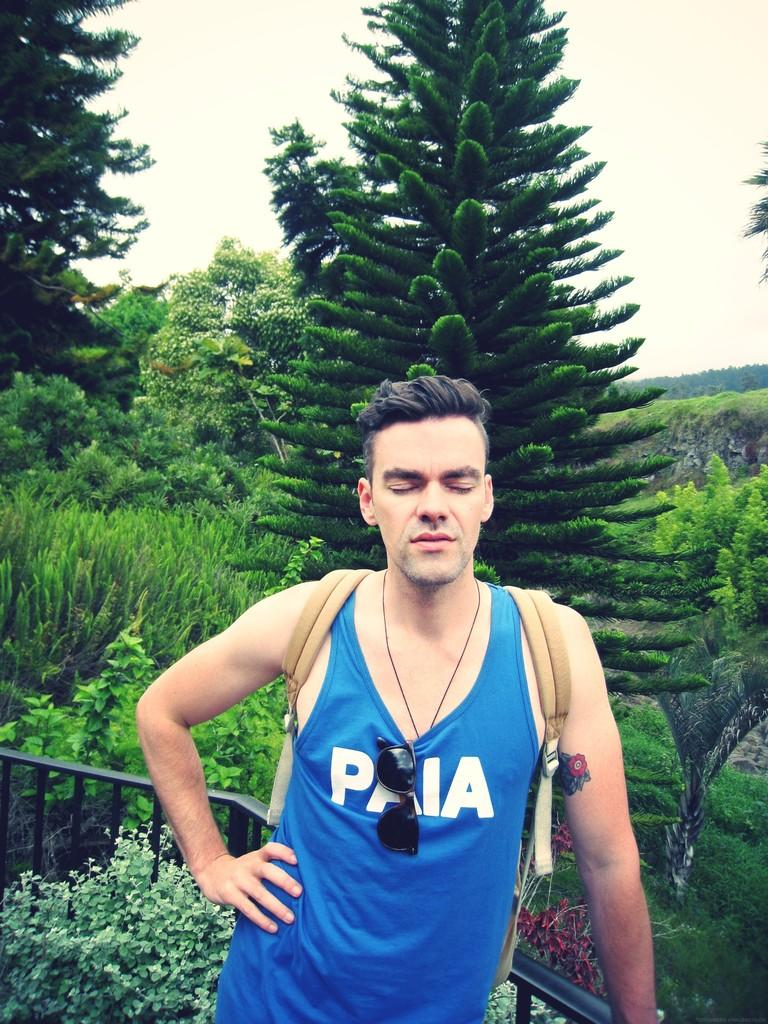<image>
Summarize the visual content of the image. A man stands with eyes closed while wearing a blue shirt with the letters PAIA written across the front of it. 